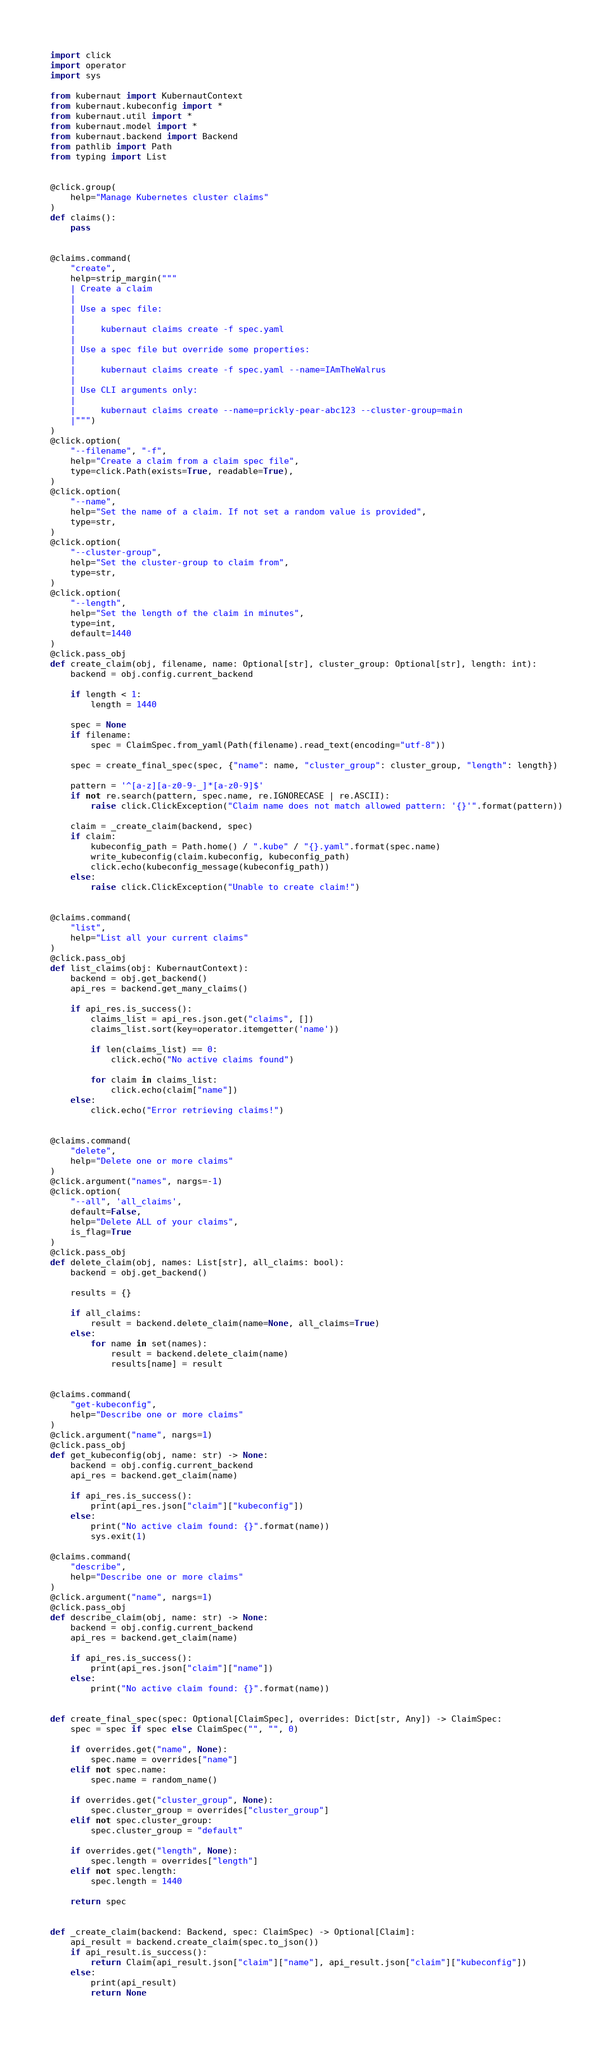<code> <loc_0><loc_0><loc_500><loc_500><_Python_>import click
import operator
import sys

from kubernaut import KubernautContext
from kubernaut.kubeconfig import *
from kubernaut.util import *
from kubernaut.model import *
from kubernaut.backend import Backend
from pathlib import Path
from typing import List


@click.group(
    help="Manage Kubernetes cluster claims"
)
def claims():
    pass


@claims.command(
    "create",
    help=strip_margin("""
    | Create a claim
    |
    | Use a spec file:
    |
    |     kubernaut claims create -f spec.yaml
    |
    | Use a spec file but override some properties:
    |
    |     kubernaut claims create -f spec.yaml --name=IAmTheWalrus
    |
    | Use CLI arguments only:
    |
    |     kubernaut claims create --name=prickly-pear-abc123 --cluster-group=main
    |""")
)
@click.option(
    "--filename", "-f",
    help="Create a claim from a claim spec file",
    type=click.Path(exists=True, readable=True),
)
@click.option(
    "--name",
    help="Set the name of a claim. If not set a random value is provided",
    type=str,
)
@click.option(
    "--cluster-group",
    help="Set the cluster-group to claim from",
    type=str,
)
@click.option(
    "--length",
    help="Set the length of the claim in minutes",
    type=int,
    default=1440
)
@click.pass_obj
def create_claim(obj, filename, name: Optional[str], cluster_group: Optional[str], length: int):
    backend = obj.config.current_backend

    if length < 1:
        length = 1440

    spec = None
    if filename:
        spec = ClaimSpec.from_yaml(Path(filename).read_text(encoding="utf-8"))

    spec = create_final_spec(spec, {"name": name, "cluster_group": cluster_group, "length": length})

    pattern = '^[a-z][a-z0-9-_]*[a-z0-9]$'
    if not re.search(pattern, spec.name, re.IGNORECASE | re.ASCII):
        raise click.ClickException("Claim name does not match allowed pattern: '{}'".format(pattern))

    claim = _create_claim(backend, spec)
    if claim:
        kubeconfig_path = Path.home() / ".kube" / "{}.yaml".format(spec.name)
        write_kubeconfig(claim.kubeconfig, kubeconfig_path)
        click.echo(kubeconfig_message(kubeconfig_path))
    else:
        raise click.ClickException("Unable to create claim!")


@claims.command(
    "list",
    help="List all your current claims"
)
@click.pass_obj
def list_claims(obj: KubernautContext):
    backend = obj.get_backend()
    api_res = backend.get_many_claims()

    if api_res.is_success():
        claims_list = api_res.json.get("claims", [])
        claims_list.sort(key=operator.itemgetter('name'))

        if len(claims_list) == 0:
            click.echo("No active claims found")

        for claim in claims_list:
            click.echo(claim["name"])
    else:
        click.echo("Error retrieving claims!")


@claims.command(
    "delete",
    help="Delete one or more claims"
)
@click.argument("names", nargs=-1)
@click.option(
    "--all", 'all_claims',
    default=False,
    help="Delete ALL of your claims",
    is_flag=True
)
@click.pass_obj
def delete_claim(obj, names: List[str], all_claims: bool):
    backend = obj.get_backend()

    results = {}

    if all_claims:
        result = backend.delete_claim(name=None, all_claims=True)
    else:
        for name in set(names):
            result = backend.delete_claim(name)
            results[name] = result


@claims.command(
    "get-kubeconfig",
    help="Describe one or more claims"
)
@click.argument("name", nargs=1)
@click.pass_obj
def get_kubeconfig(obj, name: str) -> None:
    backend = obj.config.current_backend
    api_res = backend.get_claim(name)

    if api_res.is_success():
        print(api_res.json["claim"]["kubeconfig"])
    else:
        print("No active claim found: {}".format(name))
        sys.exit(1)

@claims.command(
    "describe",
    help="Describe one or more claims"
)
@click.argument("name", nargs=1)
@click.pass_obj
def describe_claim(obj, name: str) -> None:
    backend = obj.config.current_backend
    api_res = backend.get_claim(name)

    if api_res.is_success():
        print(api_res.json["claim"]["name"])
    else:
        print("No active claim found: {}".format(name))


def create_final_spec(spec: Optional[ClaimSpec], overrides: Dict[str, Any]) -> ClaimSpec:
    spec = spec if spec else ClaimSpec("", "", 0)

    if overrides.get("name", None):
        spec.name = overrides["name"]
    elif not spec.name:
        spec.name = random_name()

    if overrides.get("cluster_group", None):
        spec.cluster_group = overrides["cluster_group"]
    elif not spec.cluster_group:
        spec.cluster_group = "default"

    if overrides.get("length", None):
        spec.length = overrides["length"]
    elif not spec.length:
        spec.length = 1440

    return spec


def _create_claim(backend: Backend, spec: ClaimSpec) -> Optional[Claim]:
    api_result = backend.create_claim(spec.to_json())
    if api_result.is_success():
        return Claim(api_result.json["claim"]["name"], api_result.json["claim"]["kubeconfig"])
    else:
        print(api_result)
        return None
</code> 